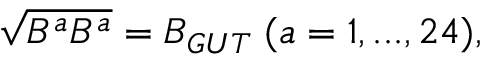<formula> <loc_0><loc_0><loc_500><loc_500>\sqrt { B ^ { a } B ^ { a } } = B _ { G U T } \, ( a = 1 , \dots , 2 4 ) ,</formula> 